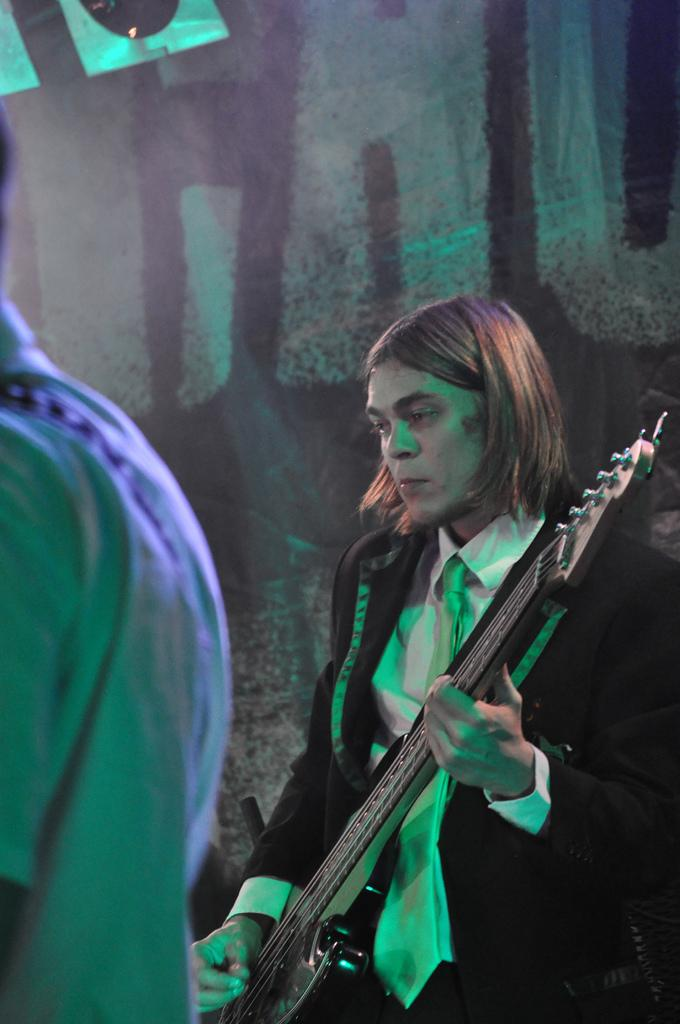What is the man in the image doing? The man is playing a guitar in the image. Can you describe the man's hair? The man has short hair. What position is the man in? The man is standing in the image. What can be seen on the left side of the image? There is a partial part of a human on the left side of the image. What type of stem can be seen growing from the man's guitar in the image? There is no stem growing from the man's guitar in the image. 